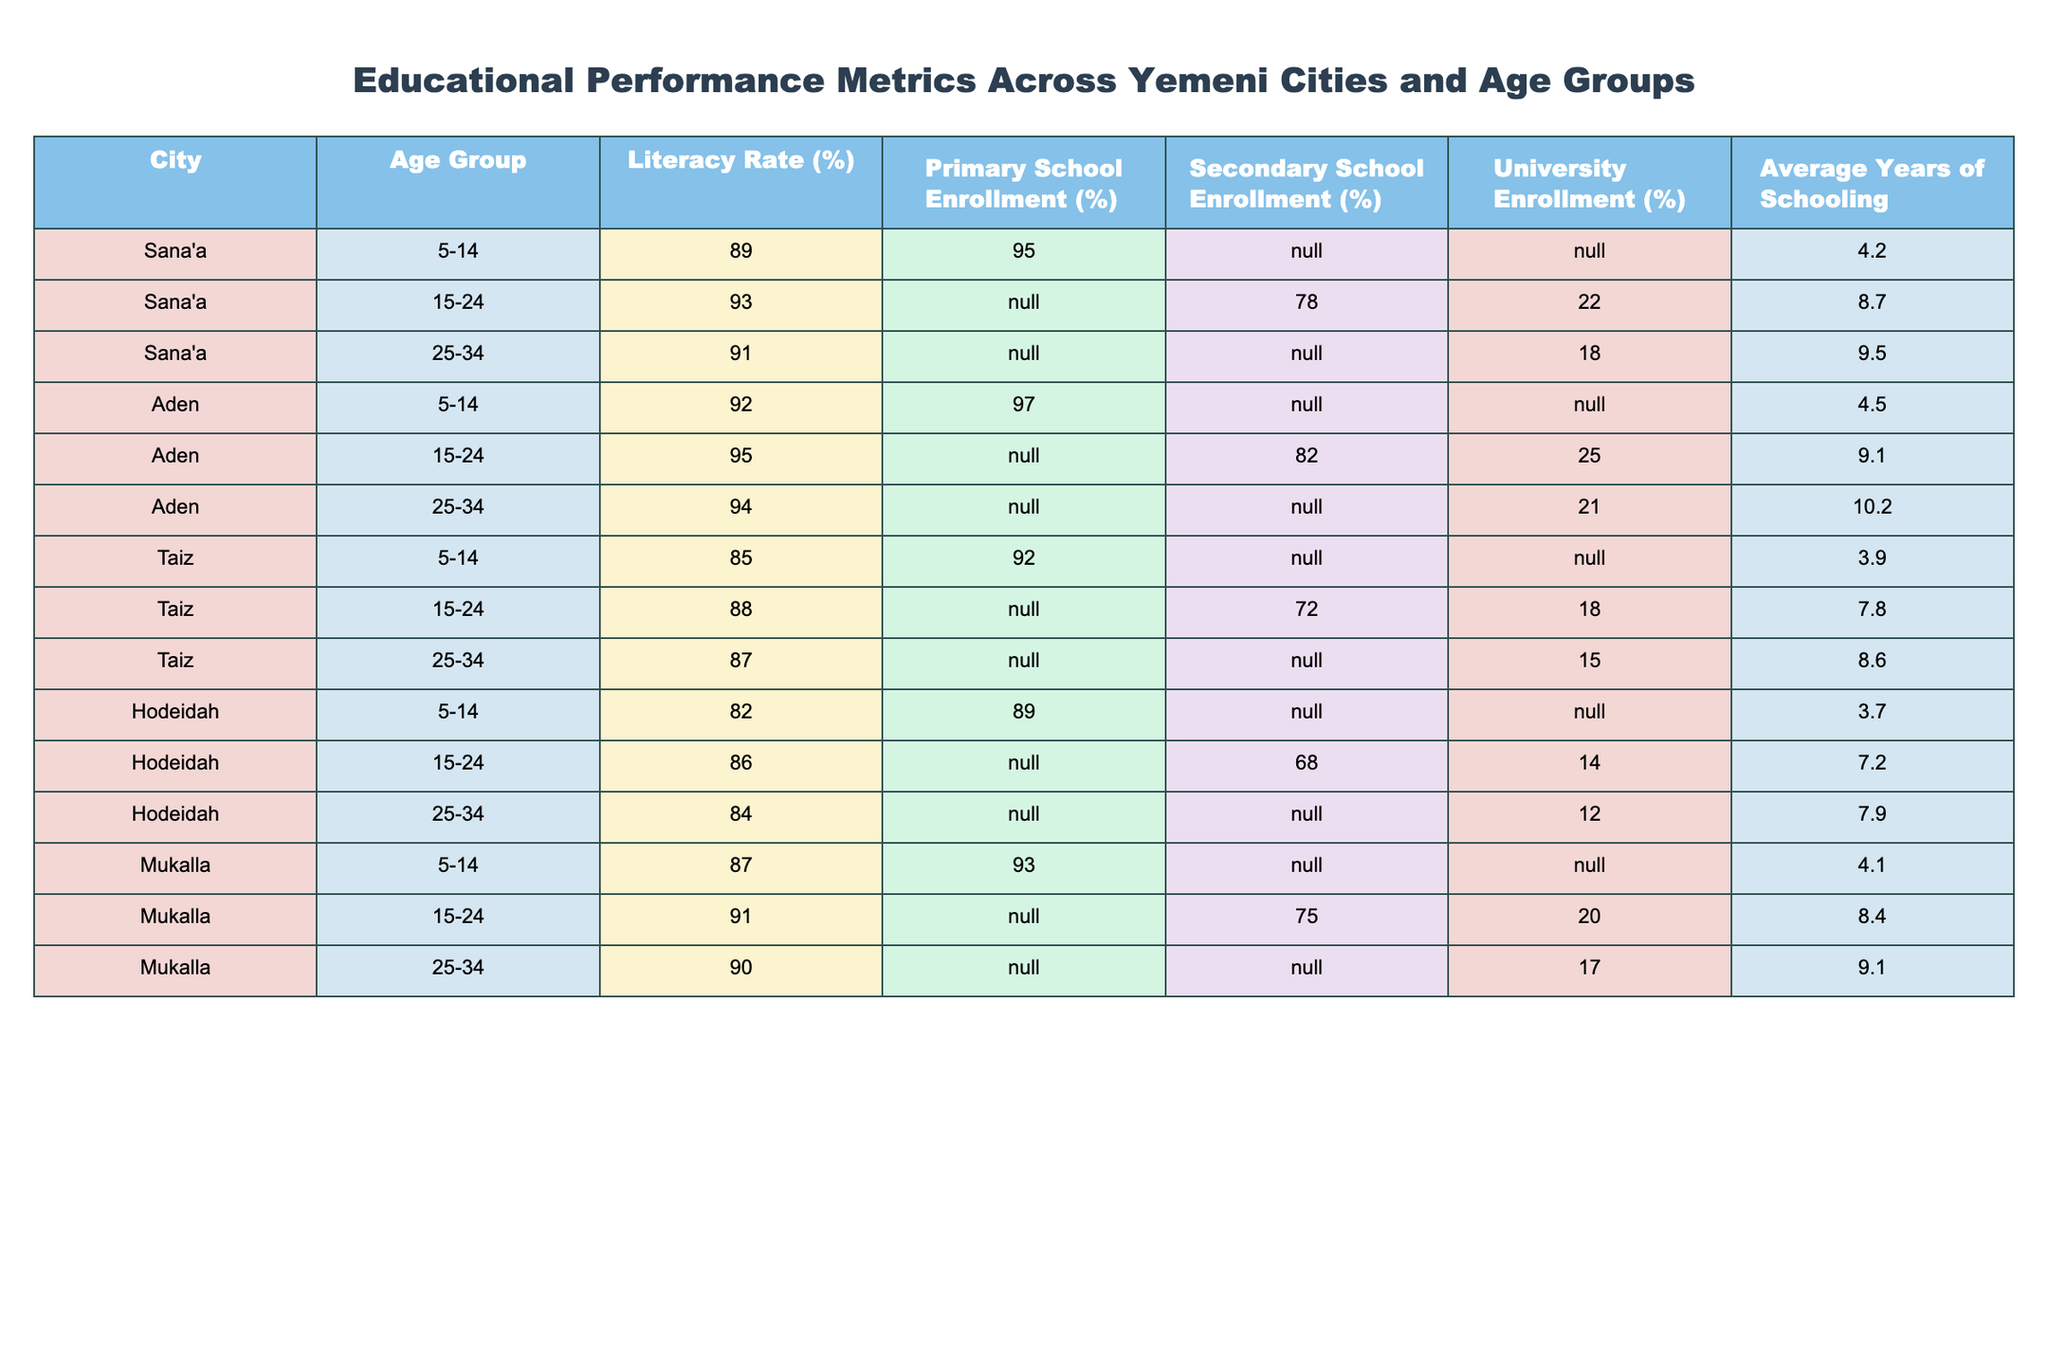What is the literacy rate for the age group 15-24 in Aden? The table shows that the literacy rate for the age group 15-24 in Aden is listed as 95%.
Answer: 95% Which city has the highest university enrollment percentage among the age group 15-24? By comparing the university enrollment percentages for the age group 15-24, Aden has 25%, Sana'a has 22%, Mukalla has 20%, Taiz has 18%, and Hodeidah has 14%. Aden has the highest percentage at 25%.
Answer: Aden What is the average literacy rate for the age group 5-14 across all cities? The literacy rates for the age group 5-14 are: Sana'a (89%), Aden (92%), Taiz (85%), Hodeidah (82%), Mukalla (87%). The average is (89 + 92 + 85 + 82 + 87) / 5 = 87%.
Answer: 87% Is the secondary school enrollment rate for the age group 15-24 in Taiz higher than that in Hodeidah? In Taiz, the secondary school enrollment rate is 72%, while in Hodeidah, it is 68%. Since 72% is greater than 68%, the statement is true.
Answer: Yes What is the difference in the average years of schooling between the age group 25-34 in Aden and Taiz? The average years of schooling for the age group 25-34 in Aden is 10.2 years, while in Taiz, it is 8.6 years. The difference is 10.2 - 8.6 = 1.6 years.
Answer: 1.6 years In which city does the age group 5-14 have the lowest primary school enrollment percentage? The primary school enrollment percentages for the age group 5-14 are: Sana'a (95%), Aden (97%), Taiz (92%), Hodeidah (89%), Mukalla (93%). Hodeidah has the lowest at 89%.
Answer: Hodeidah If we consider all age groups, which city has the highest average years of schooling? The average years of schooling for each city are as follows: Sana'a (8.7), Aden (10.2), Taiz (8.6), Hodeidah (7.9), Mukalla (9.1). Aden has the highest average at 10.2 years.
Answer: Aden Is the literacy rate for the age group 15-24 in Taiz higher than that in Sana'a? In Taiz, the literacy rate for the age group 15-24 is 88%, while in Sana'a, it is 93%. Since 88% is less than 93%, the statement is false.
Answer: No 